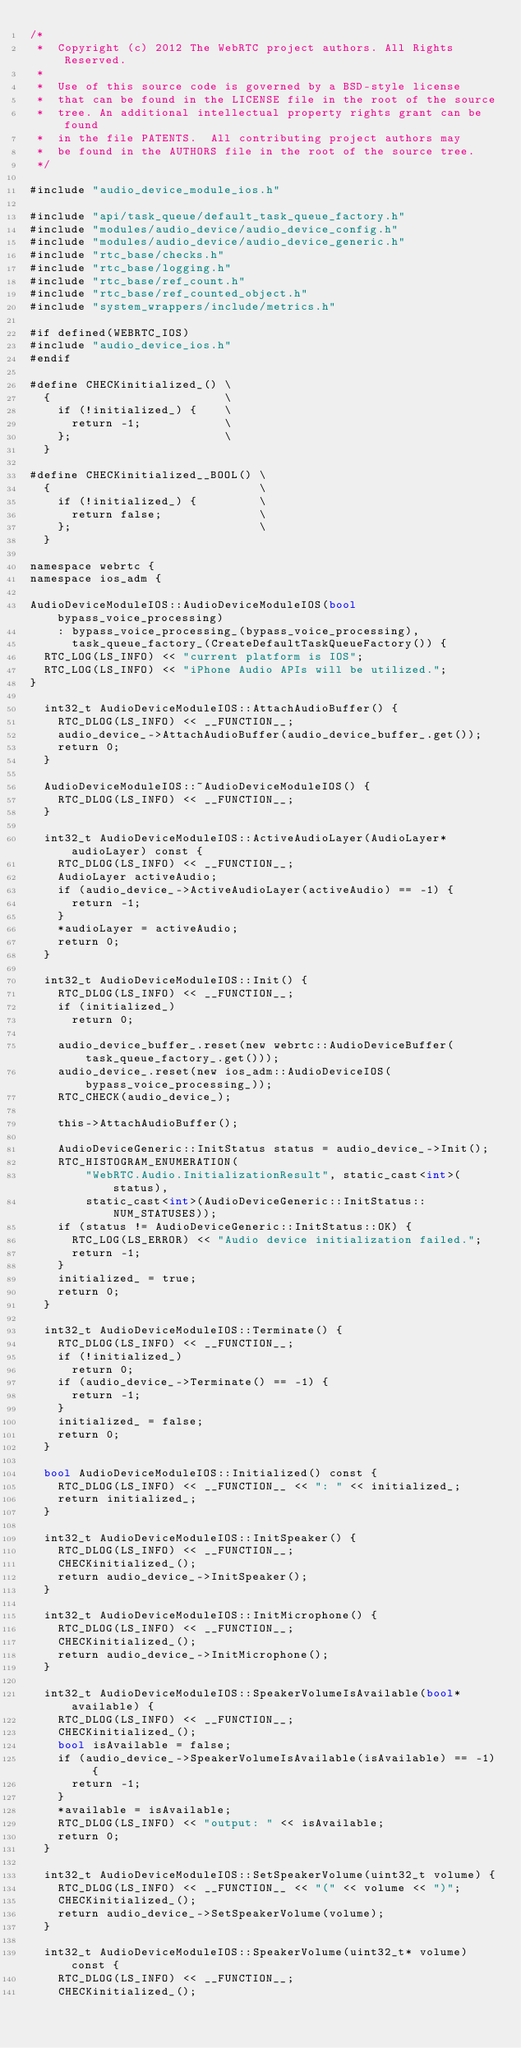Convert code to text. <code><loc_0><loc_0><loc_500><loc_500><_ObjectiveC_>/*
 *  Copyright (c) 2012 The WebRTC project authors. All Rights Reserved.
 *
 *  Use of this source code is governed by a BSD-style license
 *  that can be found in the LICENSE file in the root of the source
 *  tree. An additional intellectual property rights grant can be found
 *  in the file PATENTS.  All contributing project authors may
 *  be found in the AUTHORS file in the root of the source tree.
 */

#include "audio_device_module_ios.h"

#include "api/task_queue/default_task_queue_factory.h"
#include "modules/audio_device/audio_device_config.h"
#include "modules/audio_device/audio_device_generic.h"
#include "rtc_base/checks.h"
#include "rtc_base/logging.h"
#include "rtc_base/ref_count.h"
#include "rtc_base/ref_counted_object.h"
#include "system_wrappers/include/metrics.h"

#if defined(WEBRTC_IOS)
#include "audio_device_ios.h"
#endif

#define CHECKinitialized_() \
  {                         \
    if (!initialized_) {    \
      return -1;            \
    };                      \
  }

#define CHECKinitialized__BOOL() \
  {                              \
    if (!initialized_) {         \
      return false;              \
    };                           \
  }

namespace webrtc {
namespace ios_adm {

AudioDeviceModuleIOS::AudioDeviceModuleIOS(bool bypass_voice_processing)
    : bypass_voice_processing_(bypass_voice_processing),
      task_queue_factory_(CreateDefaultTaskQueueFactory()) {
  RTC_LOG(LS_INFO) << "current platform is IOS";
  RTC_LOG(LS_INFO) << "iPhone Audio APIs will be utilized.";
}

  int32_t AudioDeviceModuleIOS::AttachAudioBuffer() {
    RTC_DLOG(LS_INFO) << __FUNCTION__;
    audio_device_->AttachAudioBuffer(audio_device_buffer_.get());
    return 0;
  }

  AudioDeviceModuleIOS::~AudioDeviceModuleIOS() {
    RTC_DLOG(LS_INFO) << __FUNCTION__;
  }

  int32_t AudioDeviceModuleIOS::ActiveAudioLayer(AudioLayer* audioLayer) const {
    RTC_DLOG(LS_INFO) << __FUNCTION__;
    AudioLayer activeAudio;
    if (audio_device_->ActiveAudioLayer(activeAudio) == -1) {
      return -1;
    }
    *audioLayer = activeAudio;
    return 0;
  }

  int32_t AudioDeviceModuleIOS::Init() {
    RTC_DLOG(LS_INFO) << __FUNCTION__;
    if (initialized_)
      return 0;

    audio_device_buffer_.reset(new webrtc::AudioDeviceBuffer(task_queue_factory_.get()));
    audio_device_.reset(new ios_adm::AudioDeviceIOS(bypass_voice_processing_));
    RTC_CHECK(audio_device_);

    this->AttachAudioBuffer();

    AudioDeviceGeneric::InitStatus status = audio_device_->Init();
    RTC_HISTOGRAM_ENUMERATION(
        "WebRTC.Audio.InitializationResult", static_cast<int>(status),
        static_cast<int>(AudioDeviceGeneric::InitStatus::NUM_STATUSES));
    if (status != AudioDeviceGeneric::InitStatus::OK) {
      RTC_LOG(LS_ERROR) << "Audio device initialization failed.";
      return -1;
    }
    initialized_ = true;
    return 0;
  }

  int32_t AudioDeviceModuleIOS::Terminate() {
    RTC_DLOG(LS_INFO) << __FUNCTION__;
    if (!initialized_)
      return 0;
    if (audio_device_->Terminate() == -1) {
      return -1;
    }
    initialized_ = false;
    return 0;
  }

  bool AudioDeviceModuleIOS::Initialized() const {
    RTC_DLOG(LS_INFO) << __FUNCTION__ << ": " << initialized_;
    return initialized_;
  }

  int32_t AudioDeviceModuleIOS::InitSpeaker() {
    RTC_DLOG(LS_INFO) << __FUNCTION__;
    CHECKinitialized_();
    return audio_device_->InitSpeaker();
  }

  int32_t AudioDeviceModuleIOS::InitMicrophone() {
    RTC_DLOG(LS_INFO) << __FUNCTION__;
    CHECKinitialized_();
    return audio_device_->InitMicrophone();
  }

  int32_t AudioDeviceModuleIOS::SpeakerVolumeIsAvailable(bool* available) {
    RTC_DLOG(LS_INFO) << __FUNCTION__;
    CHECKinitialized_();
    bool isAvailable = false;
    if (audio_device_->SpeakerVolumeIsAvailable(isAvailable) == -1) {
      return -1;
    }
    *available = isAvailable;
    RTC_DLOG(LS_INFO) << "output: " << isAvailable;
    return 0;
  }

  int32_t AudioDeviceModuleIOS::SetSpeakerVolume(uint32_t volume) {
    RTC_DLOG(LS_INFO) << __FUNCTION__ << "(" << volume << ")";
    CHECKinitialized_();
    return audio_device_->SetSpeakerVolume(volume);
  }

  int32_t AudioDeviceModuleIOS::SpeakerVolume(uint32_t* volume) const {
    RTC_DLOG(LS_INFO) << __FUNCTION__;
    CHECKinitialized_();</code> 